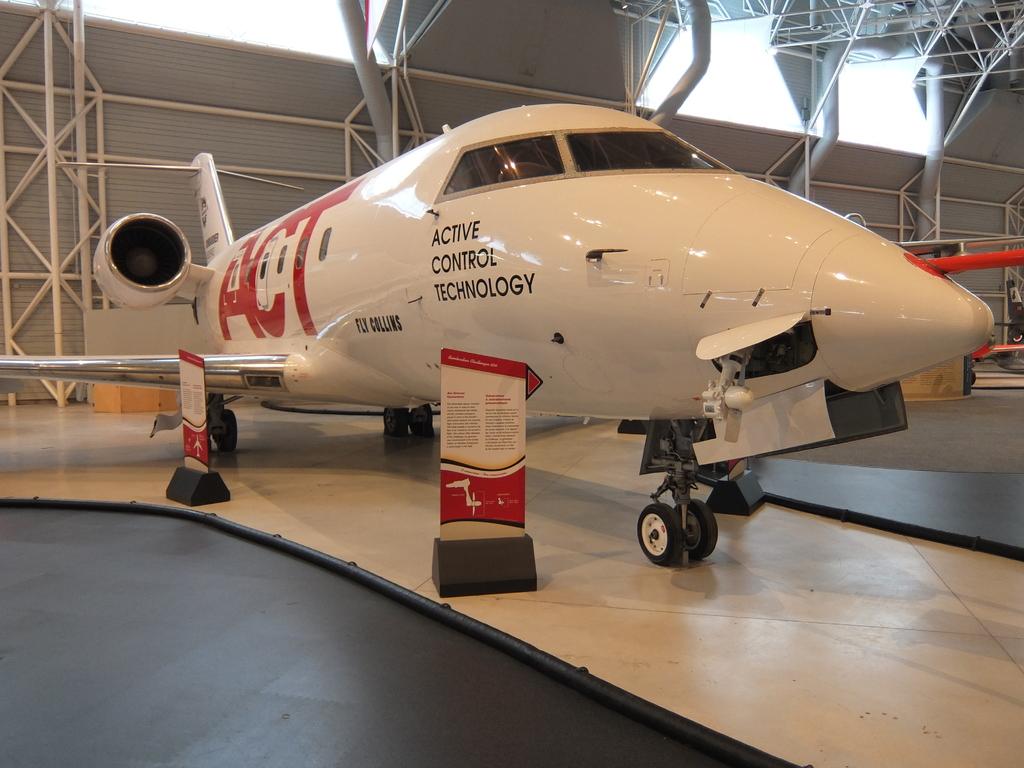What acronym is on the plane?
Provide a succinct answer. Act. What type of control technology does the plane have?
Your response must be concise. Active. 